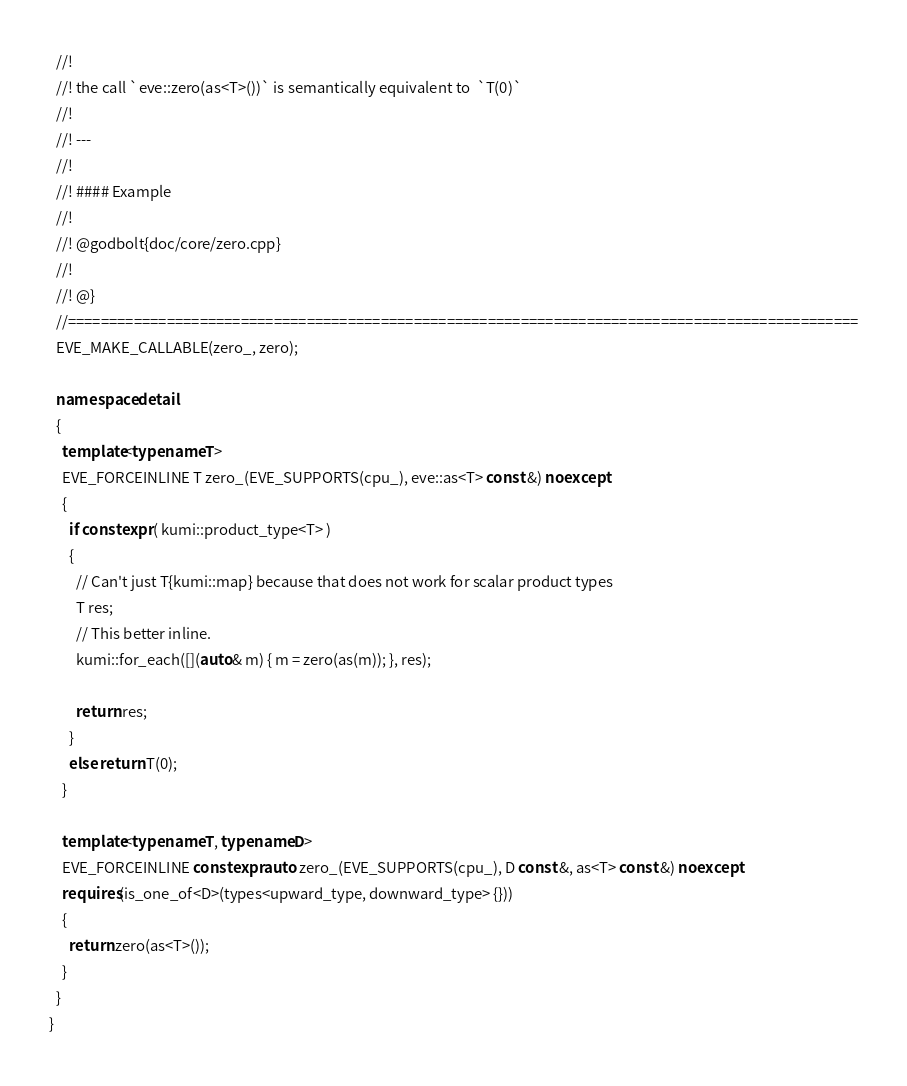<code> <loc_0><loc_0><loc_500><loc_500><_C++_>  //!
  //! the call `eve::zero(as<T>())` is semantically equivalent to  `T(0)`
  //!
  //! ---
  //!
  //! #### Example
  //!
  //! @godbolt{doc/core/zero.cpp}
  //!
  //! @}
  //================================================================================================
  EVE_MAKE_CALLABLE(zero_, zero);

  namespace detail
  {
    template<typename T>
    EVE_FORCEINLINE T zero_(EVE_SUPPORTS(cpu_), eve::as<T> const &) noexcept
    {
      if constexpr ( kumi::product_type<T> )
      {
        // Can't just T{kumi::map} because that does not work for scalar product types
        T res;
        // This better inline.
        kumi::for_each([](auto& m) { m = zero(as(m)); }, res);

        return res;
      }
      else return T(0);
    }

    template<typename T, typename D>
    EVE_FORCEINLINE constexpr auto zero_(EVE_SUPPORTS(cpu_), D const &, as<T> const &) noexcept
    requires(is_one_of<D>(types<upward_type, downward_type> {}))
    {
      return zero(as<T>());
    }
  }
}
</code> 